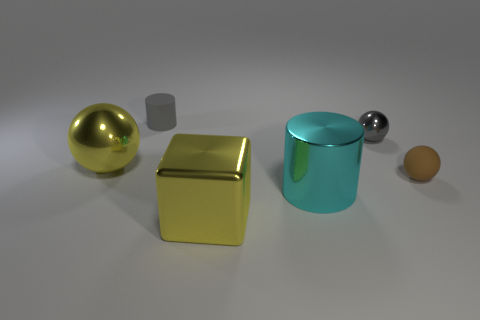Add 2 tiny brown matte balls. How many objects exist? 8 Subtract all cylinders. How many objects are left? 4 Add 2 yellow balls. How many yellow balls are left? 3 Add 1 large yellow metal objects. How many large yellow metal objects exist? 3 Subtract 0 red cylinders. How many objects are left? 6 Subtract all cubes. Subtract all small purple cylinders. How many objects are left? 5 